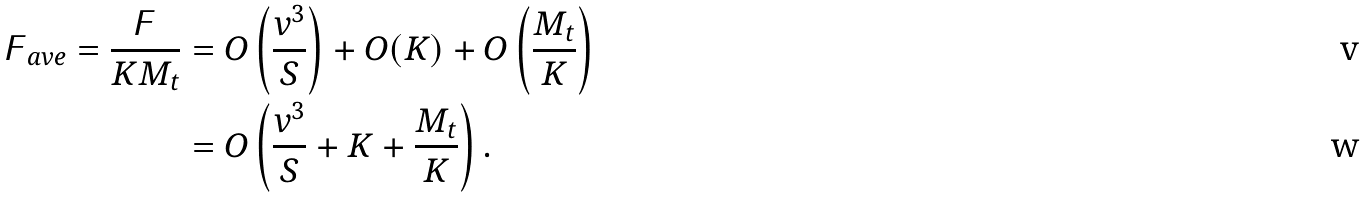<formula> <loc_0><loc_0><loc_500><loc_500>\digamma _ { a v e } = \frac { \digamma } { K M _ { t } } & = O \left ( \frac { v ^ { 3 } } { S } \right ) + O ( K ) + O \left ( \frac { M _ { t } } { K } \right ) \\ & = O \left ( \frac { v ^ { 3 } } { S } + K + \frac { M _ { t } } { K } \right ) .</formula> 